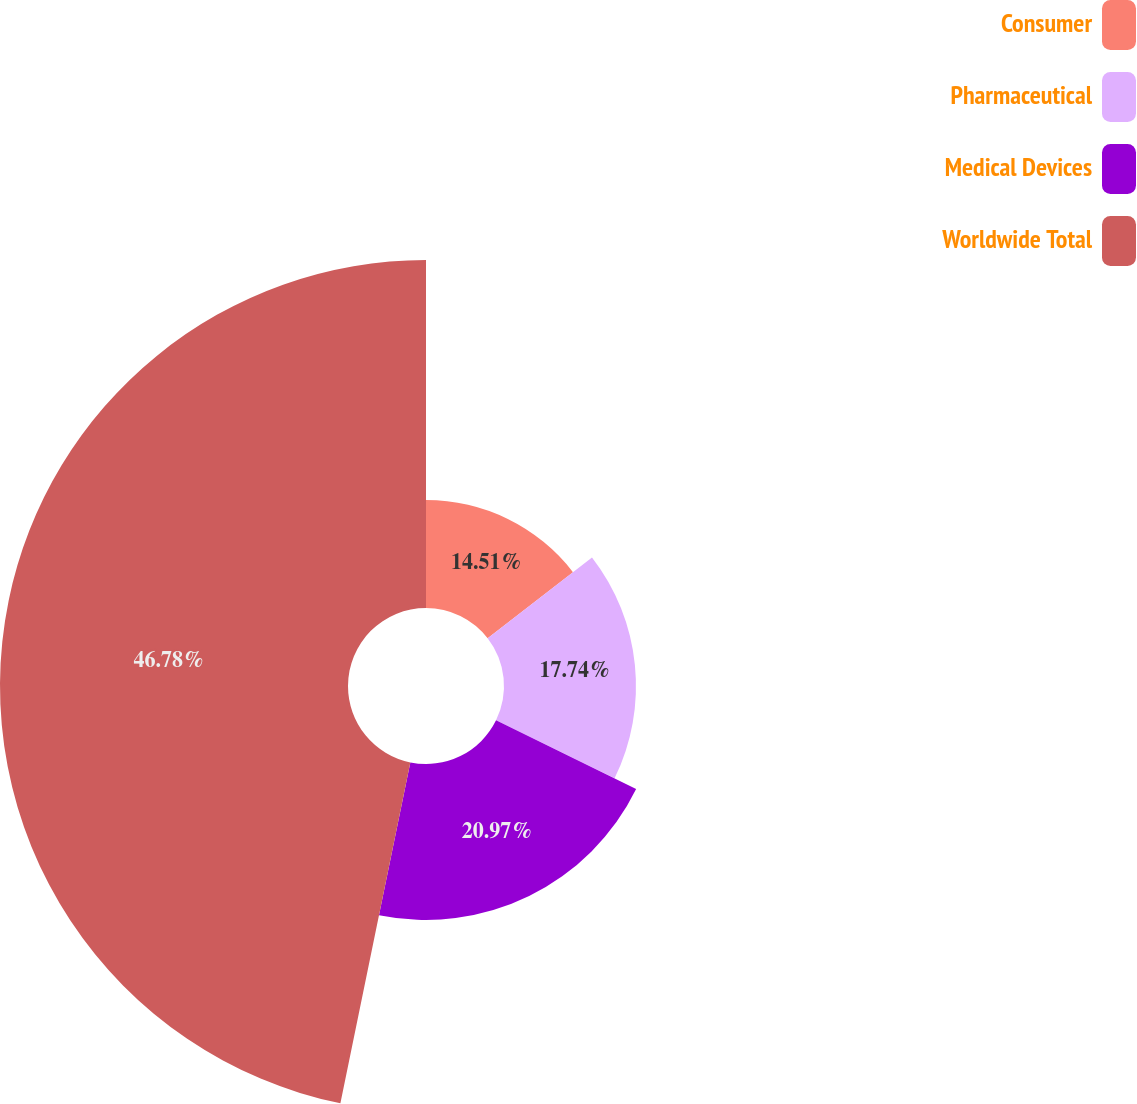<chart> <loc_0><loc_0><loc_500><loc_500><pie_chart><fcel>Consumer<fcel>Pharmaceutical<fcel>Medical Devices<fcel>Worldwide Total<nl><fcel>14.51%<fcel>17.74%<fcel>20.97%<fcel>46.78%<nl></chart> 